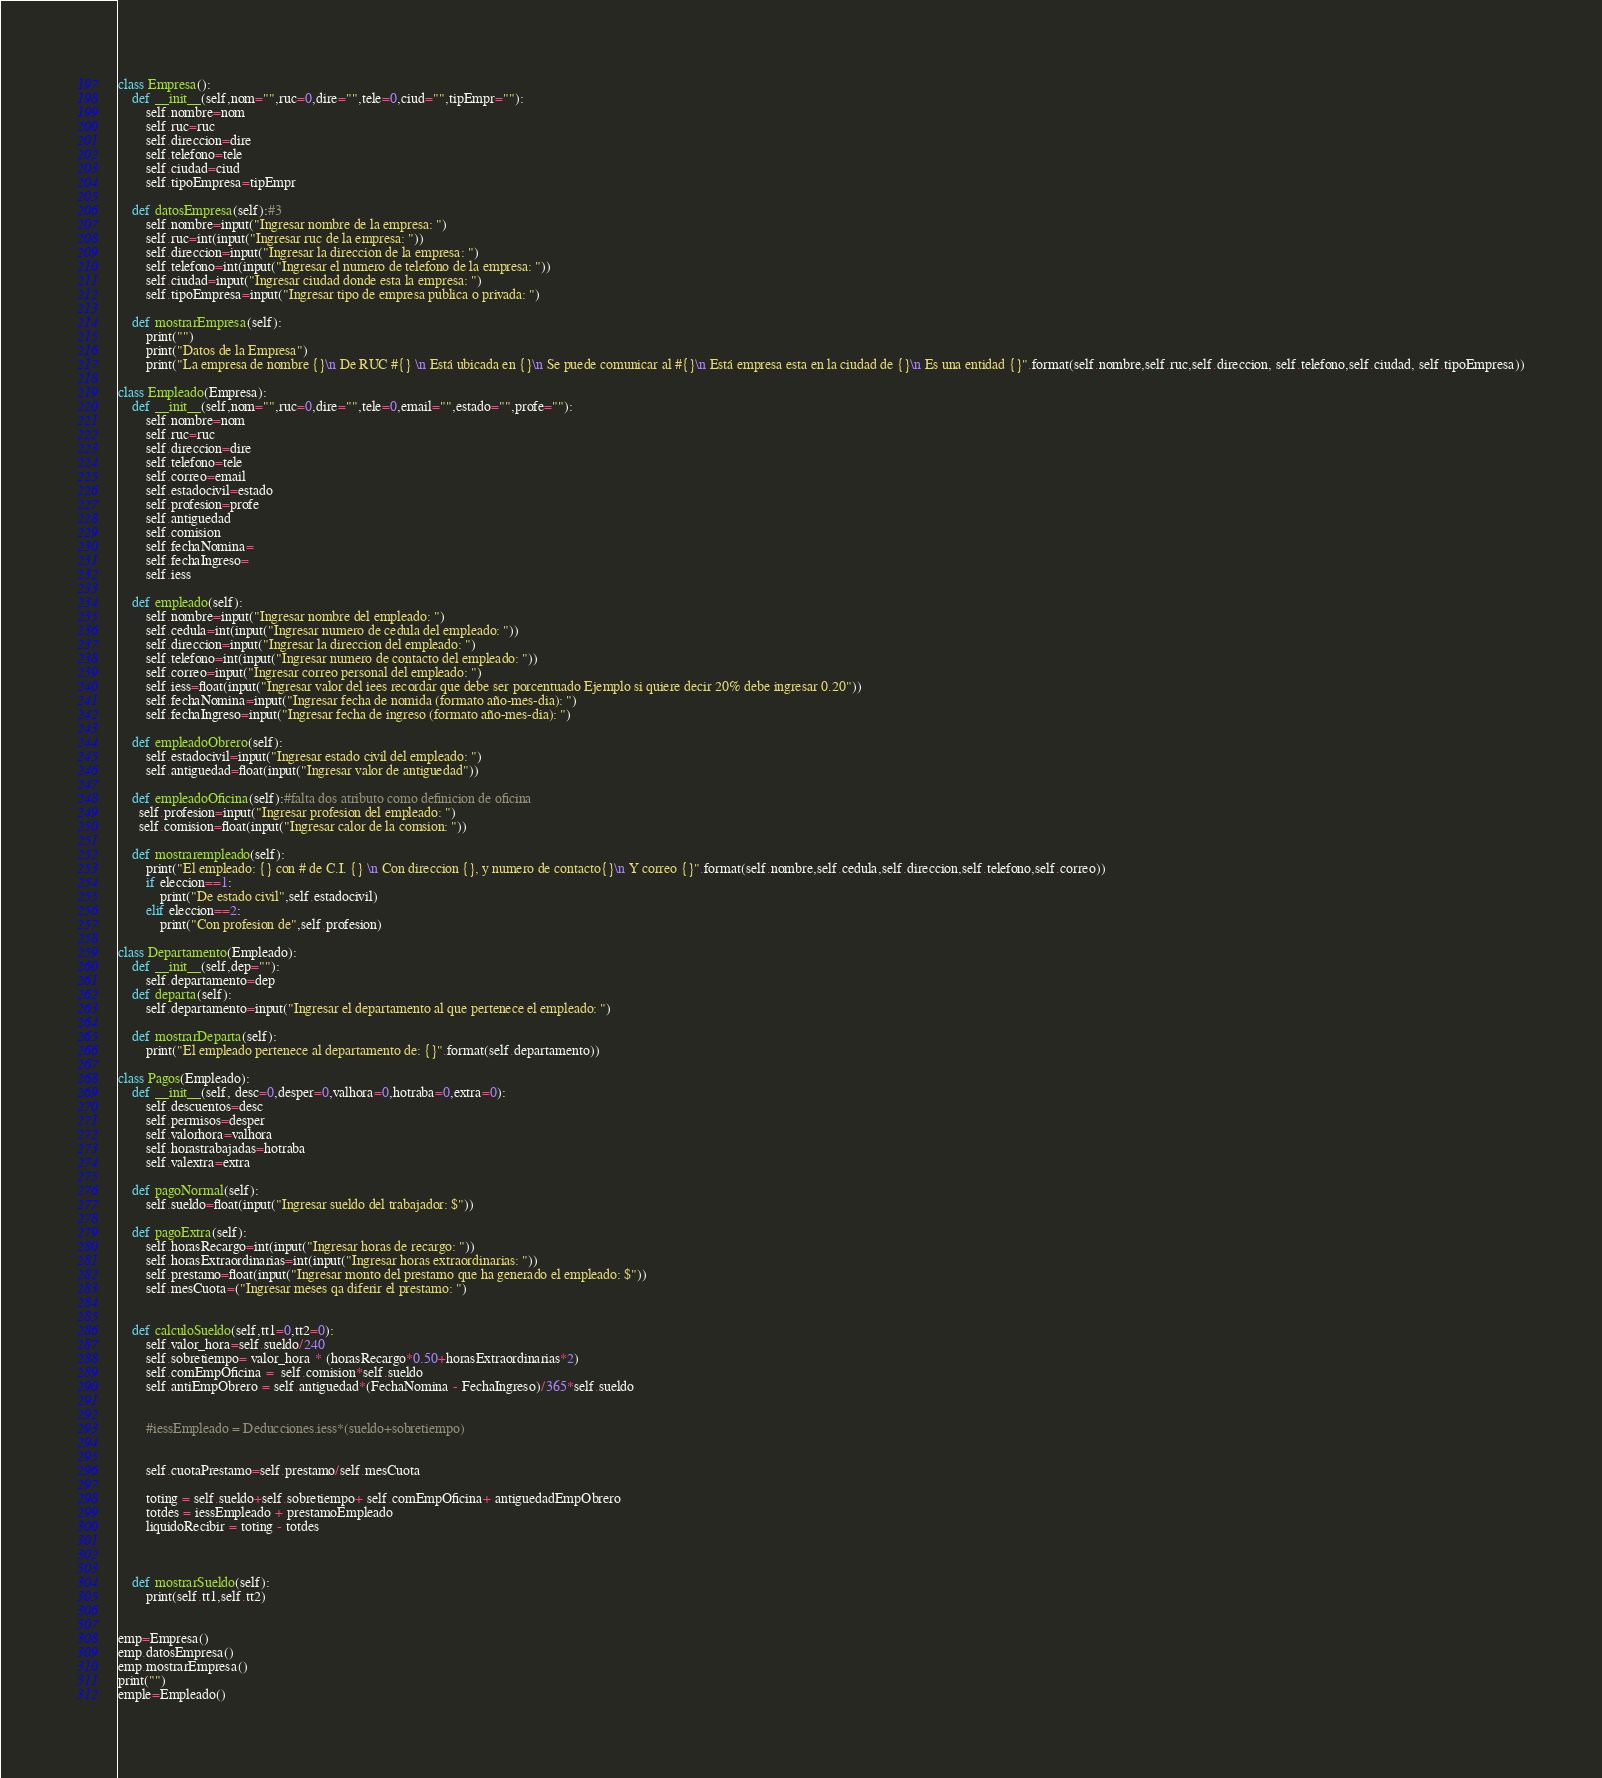Convert code to text. <code><loc_0><loc_0><loc_500><loc_500><_Python_>class Empresa():
    def __init__(self,nom="",ruc=0,dire="",tele=0,ciud="",tipEmpr=""):
        self.nombre=nom
        self.ruc=ruc
        self.direccion=dire
        self.telefono=tele
        self.ciudad=ciud
        self.tipoEmpresa=tipEmpr

    def datosEmpresa(self):#3
        self.nombre=input("Ingresar nombre de la empresa: ")
        self.ruc=int(input("Ingresar ruc de la empresa: "))
        self.direccion=input("Ingresar la direccion de la empresa: ")
        self.telefono=int(input("Ingresar el numero de telefono de la empresa: "))
        self.ciudad=input("Ingresar ciudad donde esta la empresa: ")
        self.tipoEmpresa=input("Ingresar tipo de empresa publica o privada: ")
    
    def mostrarEmpresa(self):
        print("")
        print("Datos de la Empresa")
        print("La empresa de nombre {}\n De RUC #{} \n Está ubicada en {}\n Se puede comunicar al #{}\n Está empresa esta en la ciudad de {}\n Es una entidad {}".format(self.nombre,self.ruc,self.direccion, self.telefono,self.ciudad, self.tipoEmpresa))

class Empleado(Empresa):
    def __init__(self,nom="",ruc=0,dire="",tele=0,email="",estado="",profe=""):
        self.nombre=nom
        self.ruc=ruc
        self.direccion=dire
        self.telefono=tele
        self.correo=email
        self.estadocivil=estado
        self.profesion=profe
        self.antiguedad
        self.comision
        self.fechaNomina=
        self.fechaIngreso=
        self.iess

    def empleado(self):
        self.nombre=input("Ingresar nombre del empleado: ")
        self.cedula=int(input("Ingresar numero de cedula del empleado: "))
        self.direccion=input("Ingresar la direccion del empleado: ")
        self.telefono=int(input("Ingresar numero de contacto del empleado: "))
        self.correo=input("Ingresar correo personal del empleado: ")
        self.iess=float(input("Ingresar valor del iees recordar que debe ser porcentuado Ejemplo si quiere decir 20% debe ingresar 0.20"))
        self.fechaNomina=input("Ingresar fecha de nomida (formato año-mes-dia): ")
        self.fechaIngreso=input("Ingresar fecha de ingreso (formato año-mes-dia): ")

    def empleadoObrero(self): 
        self.estadocivil=input("Ingresar estado civil del empleado: ")
        self.antiguedad=float(input("Ingresar valor de antiguedad"))

    def empleadoOficina(self):#falta dos atributo como definicion de oficina
      self.profesion=input("Ingresar profesion del empleado: ")
      self.comision=float(input("Ingresar calor de la comsion: "))

    def mostrarempleado(self):
        print("El empleado: {} con # de C.I. {} \n Con direccion {}, y numero de contacto{}\n Y correo {}".format(self.nombre,self.cedula,self.direccion,self.telefono,self.correo))
        if eleccion==1:
            print("De estado civil",self.estadocivil)
        elif eleccion==2:
            print("Con profesion de",self.profesion)  

class Departamento(Empleado):
    def __init__(self,dep=""):
        self.departamento=dep
    def departa(self):
        self.departamento=input("Ingresar el departamento al que pertenece el empleado: ")

    def mostrarDeparta(self):
        print("El empleado pertenece al departamento de: {}".format(self.departamento))

class Pagos(Empleado):
    def __init__(self, desc=0,desper=0,valhora=0,hotraba=0,extra=0):
        self.descuentos=desc
        self.permisos=desper
        self.valorhora=valhora
        self.horastrabajadas=hotraba
        self.valextra=extra

    def pagoNormal(self):
        self.sueldo=float(input("Ingresar sueldo del trabajador: $"))
        
    def pagoExtra(self):
        self.horasRecargo=int(input("Ingresar horas de recargo: "))
        self.horasExtraordinarias=int(input("Ingresar horas extraordinarias: "))
        self.prestamo=float(input("Ingresar monto del prestamo que ha generado el empleado: $"))
        self.mesCuota=("Ingresar meses qa diferir el prestamo: ")


    def calculoSueldo(self,tt1=0,tt2=0):
        self.valor_hora=self.sueldo/240
        self.sobretiempo= valor_hora * (horasRecargo*0.50+horasExtraordinarias*2)
        self.comEmpOficina =  self.comision*self.sueldo
        self.antiEmpObrero = self.antiguedad*(FechaNomina - FechaIngreso)/365*self.sueldo


        #iessEmpleado = Deducciones.iess*(sueldo+sobretiempo)


        self.cuotaPrestamo=self.prestamo/self.mesCuota

        toting = self.sueldo+self.sobretiempo+ self.comEmpOficina+ antiguedadEmpObrero
        totdes = iessEmpleado + prestamoEmpleado
        liquidoRecibir = toting - totdes



    def mostrarSueldo(self):
        print(self.tt1,self.tt2)


emp=Empresa()
emp.datosEmpresa()
emp.mostrarEmpresa()
print("")
emple=Empleado()</code> 